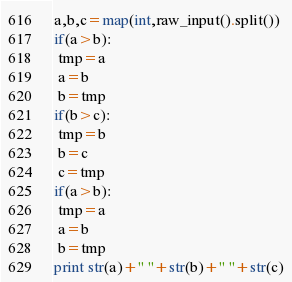Convert code to text. <code><loc_0><loc_0><loc_500><loc_500><_Python_>a,b,c=map(int,raw_input().split())
if(a>b):
 tmp=a
 a=b
 b=tmp
if(b>c):
 tmp=b
 b=c
 c=tmp
if(a>b):
 tmp=a
 a=b
 b=tmp
print str(a)+" "+str(b)+" "+str(c)</code> 